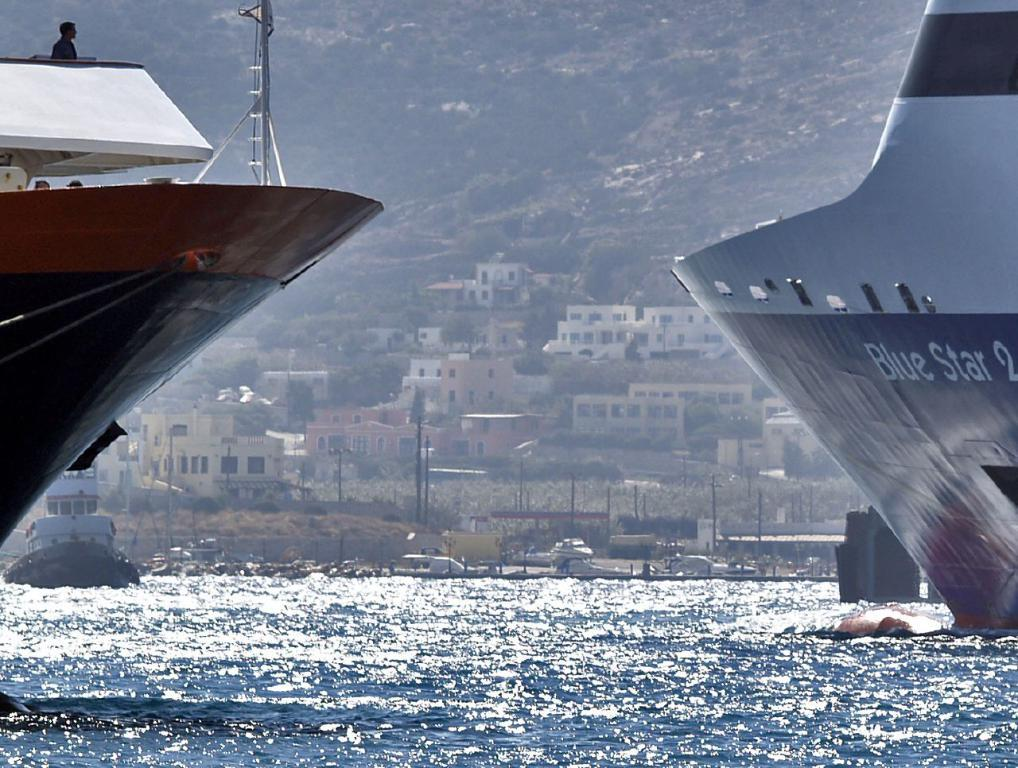<image>
Relay a brief, clear account of the picture shown. The ship named Blue Star 2 is positioned on the right. 